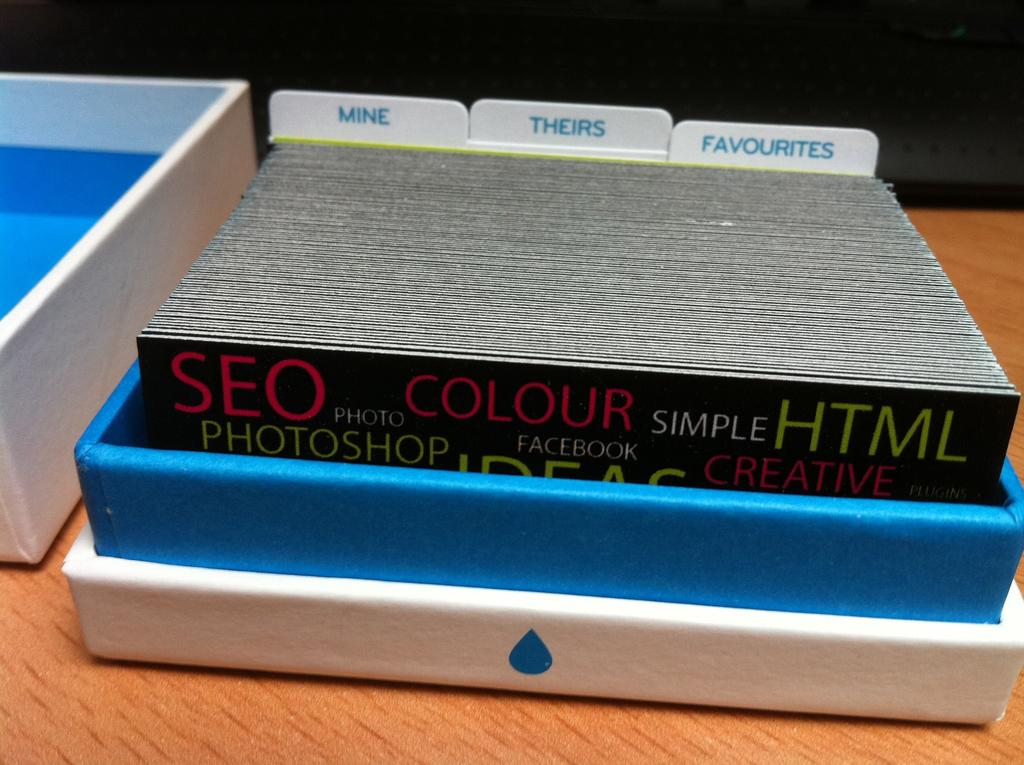<image>
Give a short and clear explanation of the subsequent image. An open box has cards in it along with tabs that say Mine, Theirs, and Favorites. 